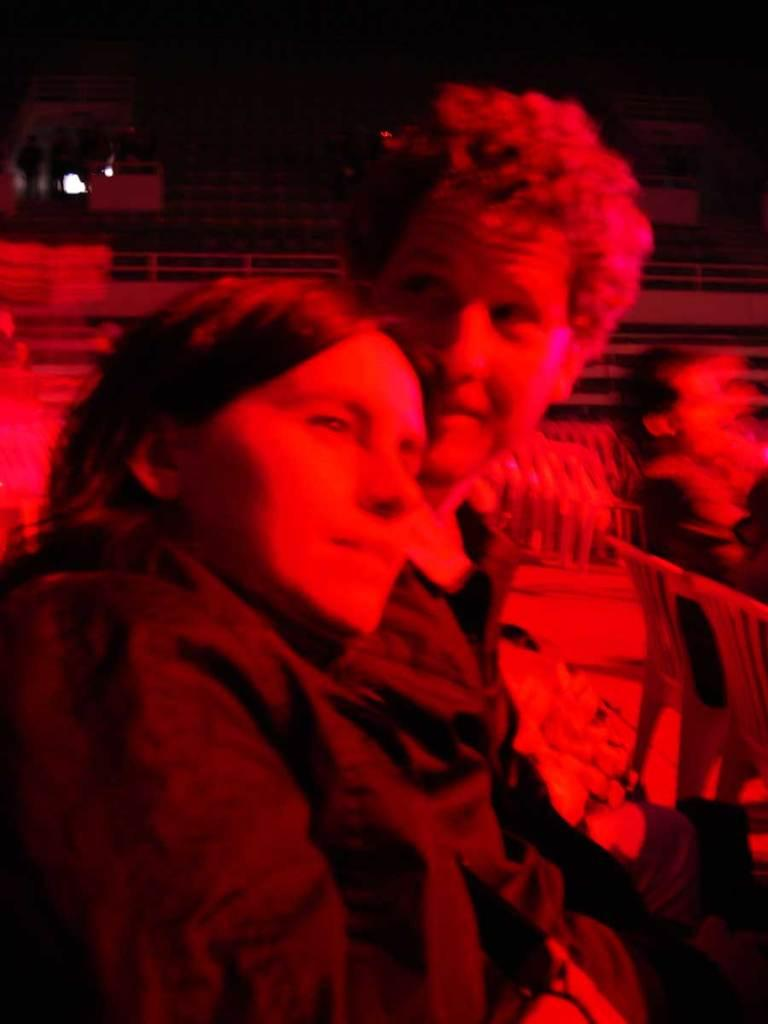Who are the people in the image? There is a woman and a man in the image. How are the woman and man positioned in the image? The woman and man are beside each other in the image. What can be observed about the lighting in the image? There is a red color light on the woman and man. How many cannons are visible in the image? There are no cannons present in the image. What type of hole can be seen in the image? There is no hole visible in the image. 